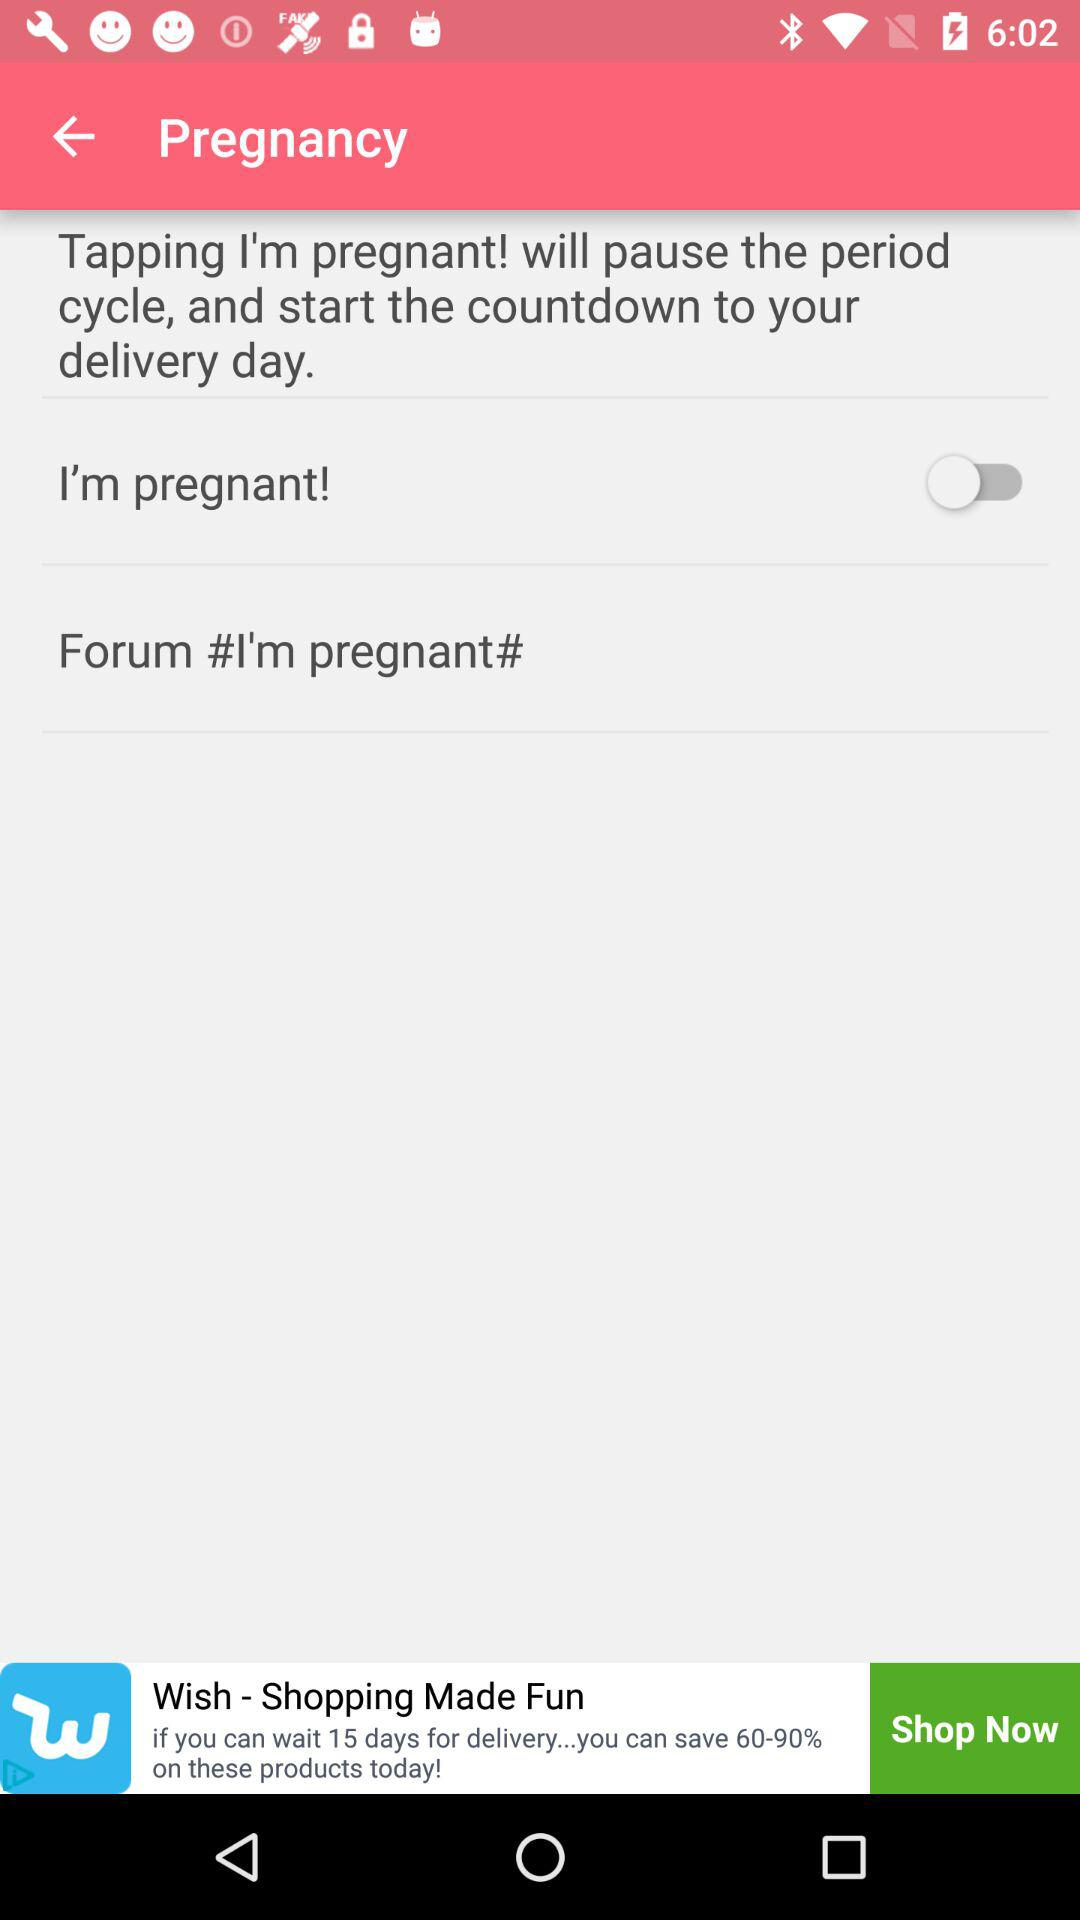How many more days will it take to ship the product if I order it today?
Answer the question using a single word or phrase. 15 